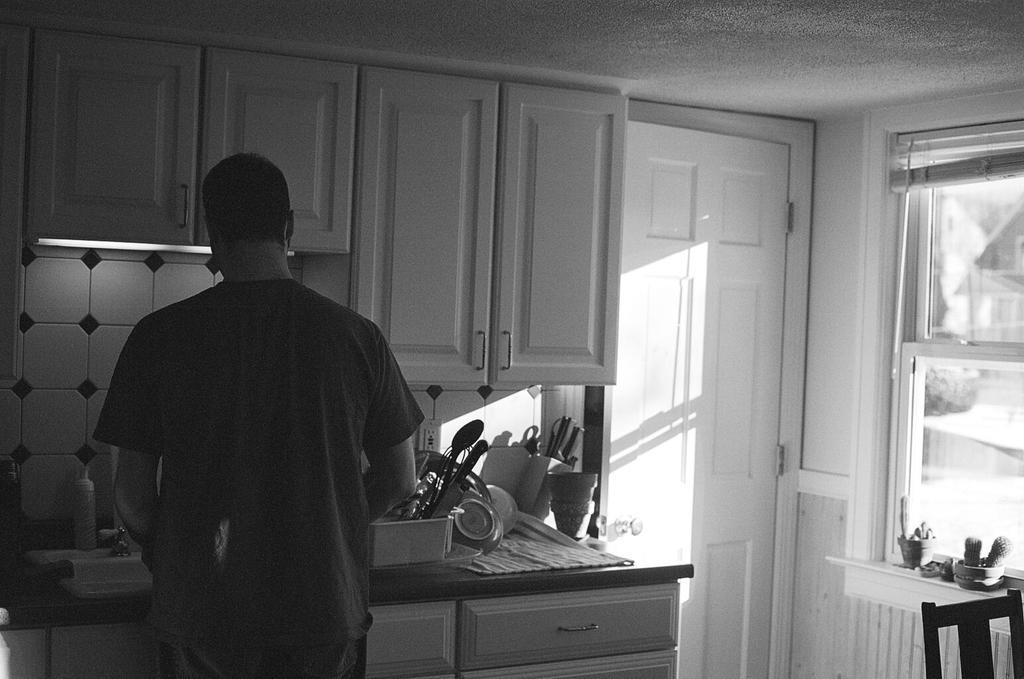How would you summarize this image in a sentence or two? This picture describes about inside view of a room, in this we can see a chair, a man and few things on the countertop, it is a black and white photography. 